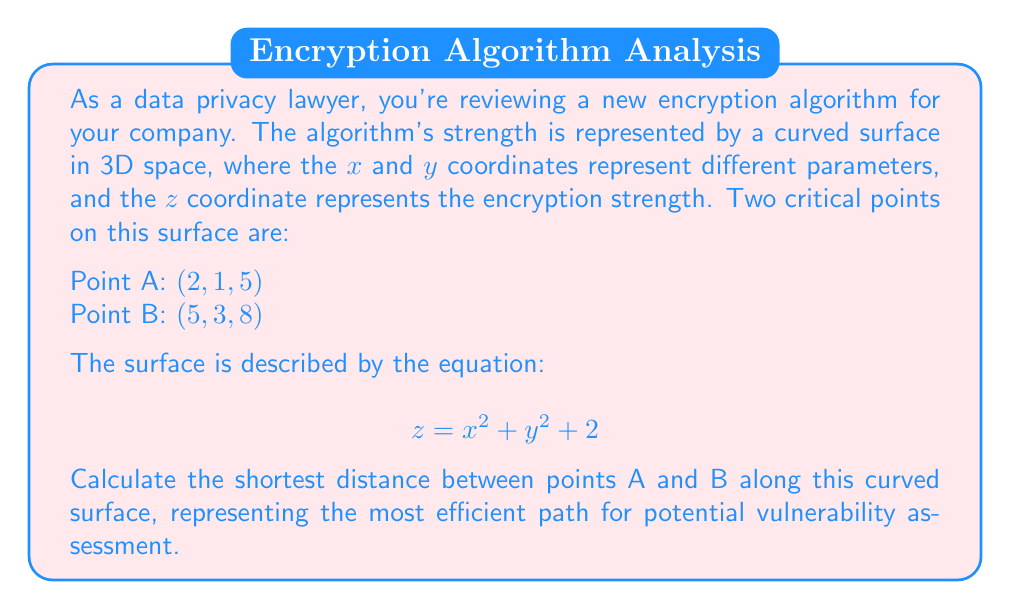Help me with this question. To solve this problem, we need to use the concept of geodesics on a curved surface. However, calculating the exact geodesic can be complex. We'll use an approximation method:

1) First, let's calculate the straight-line distance between A and B in 3D space:

   $$d = \sqrt{(x_2-x_1)^2 + (y_2-y_1)^2 + (z_2-z_1)^2}$$
   $$d = \sqrt{(5-2)^2 + (3-1)^2 + (8-5)^2}$$
   $$d = \sqrt{9 + 4 + 9} = \sqrt{22} \approx 4.69$$

2) Now, we need to account for the curvature of the surface. We can do this by calculating the average gradient between the two points:

   Gradient at A: $\nabla f(2,1) = (4, 2)$
   Gradient at B: $\nabla f(5,3) = (10, 6)$
   Average gradient: $(7, 4)$

3) The magnitude of this average gradient gives us an idea of the steepness:

   $$\|\nabla f_{avg}\| = \sqrt{7^2 + 4^2} = \sqrt{65} \approx 8.06$$

4) We can use this to create a correction factor:

   $$\text{Correction Factor} = 1 + \frac{\|\nabla f_{avg}\|}{10} = 1 + \frac{8.06}{10} \approx 1.806$$

5) Apply this correction factor to our straight-line distance:

   $$\text{Approximate shortest distance} = d \times \text{Correction Factor}$$
   $$\approx 4.69 \times 1.806 \approx 8.47$$

This approximation gives us an estimate of the shortest path along the curved surface between the two points.
Answer: The approximate shortest distance between points A and B along the curved surface is 8.47 units. 